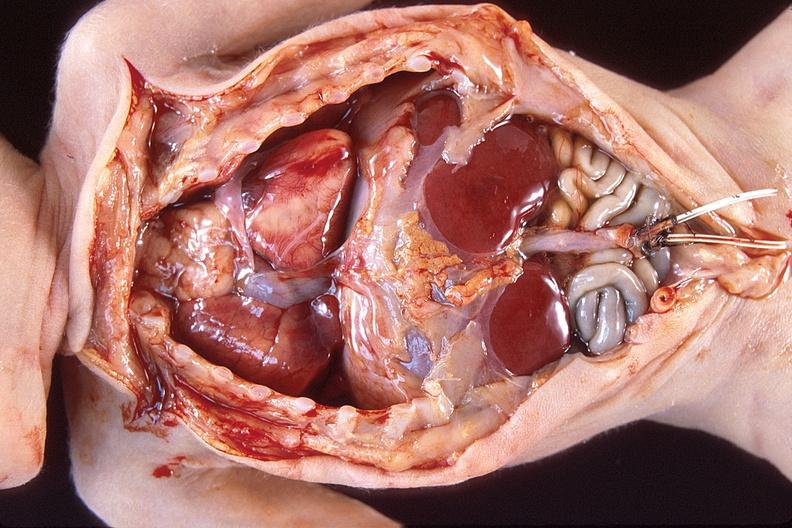what does this image show?
Answer the question using a single word or phrase. Hyaline membrane disease 